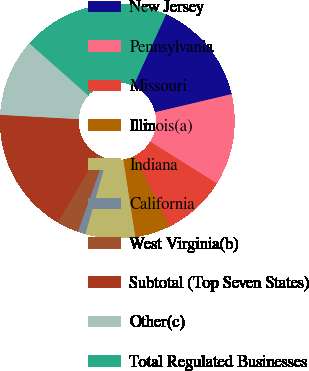<chart> <loc_0><loc_0><loc_500><loc_500><pie_chart><fcel>New Jersey<fcel>Pennsylvania<fcel>Missouri<fcel>Illinois(a)<fcel>Indiana<fcel>California<fcel>West Virginia(b)<fcel>Subtotal (Top Seven States)<fcel>Other(c)<fcel>Total Regulated Businesses<nl><fcel>14.5%<fcel>12.59%<fcel>8.75%<fcel>4.91%<fcel>6.83%<fcel>1.07%<fcel>2.99%<fcel>17.42%<fcel>10.67%<fcel>20.26%<nl></chart> 